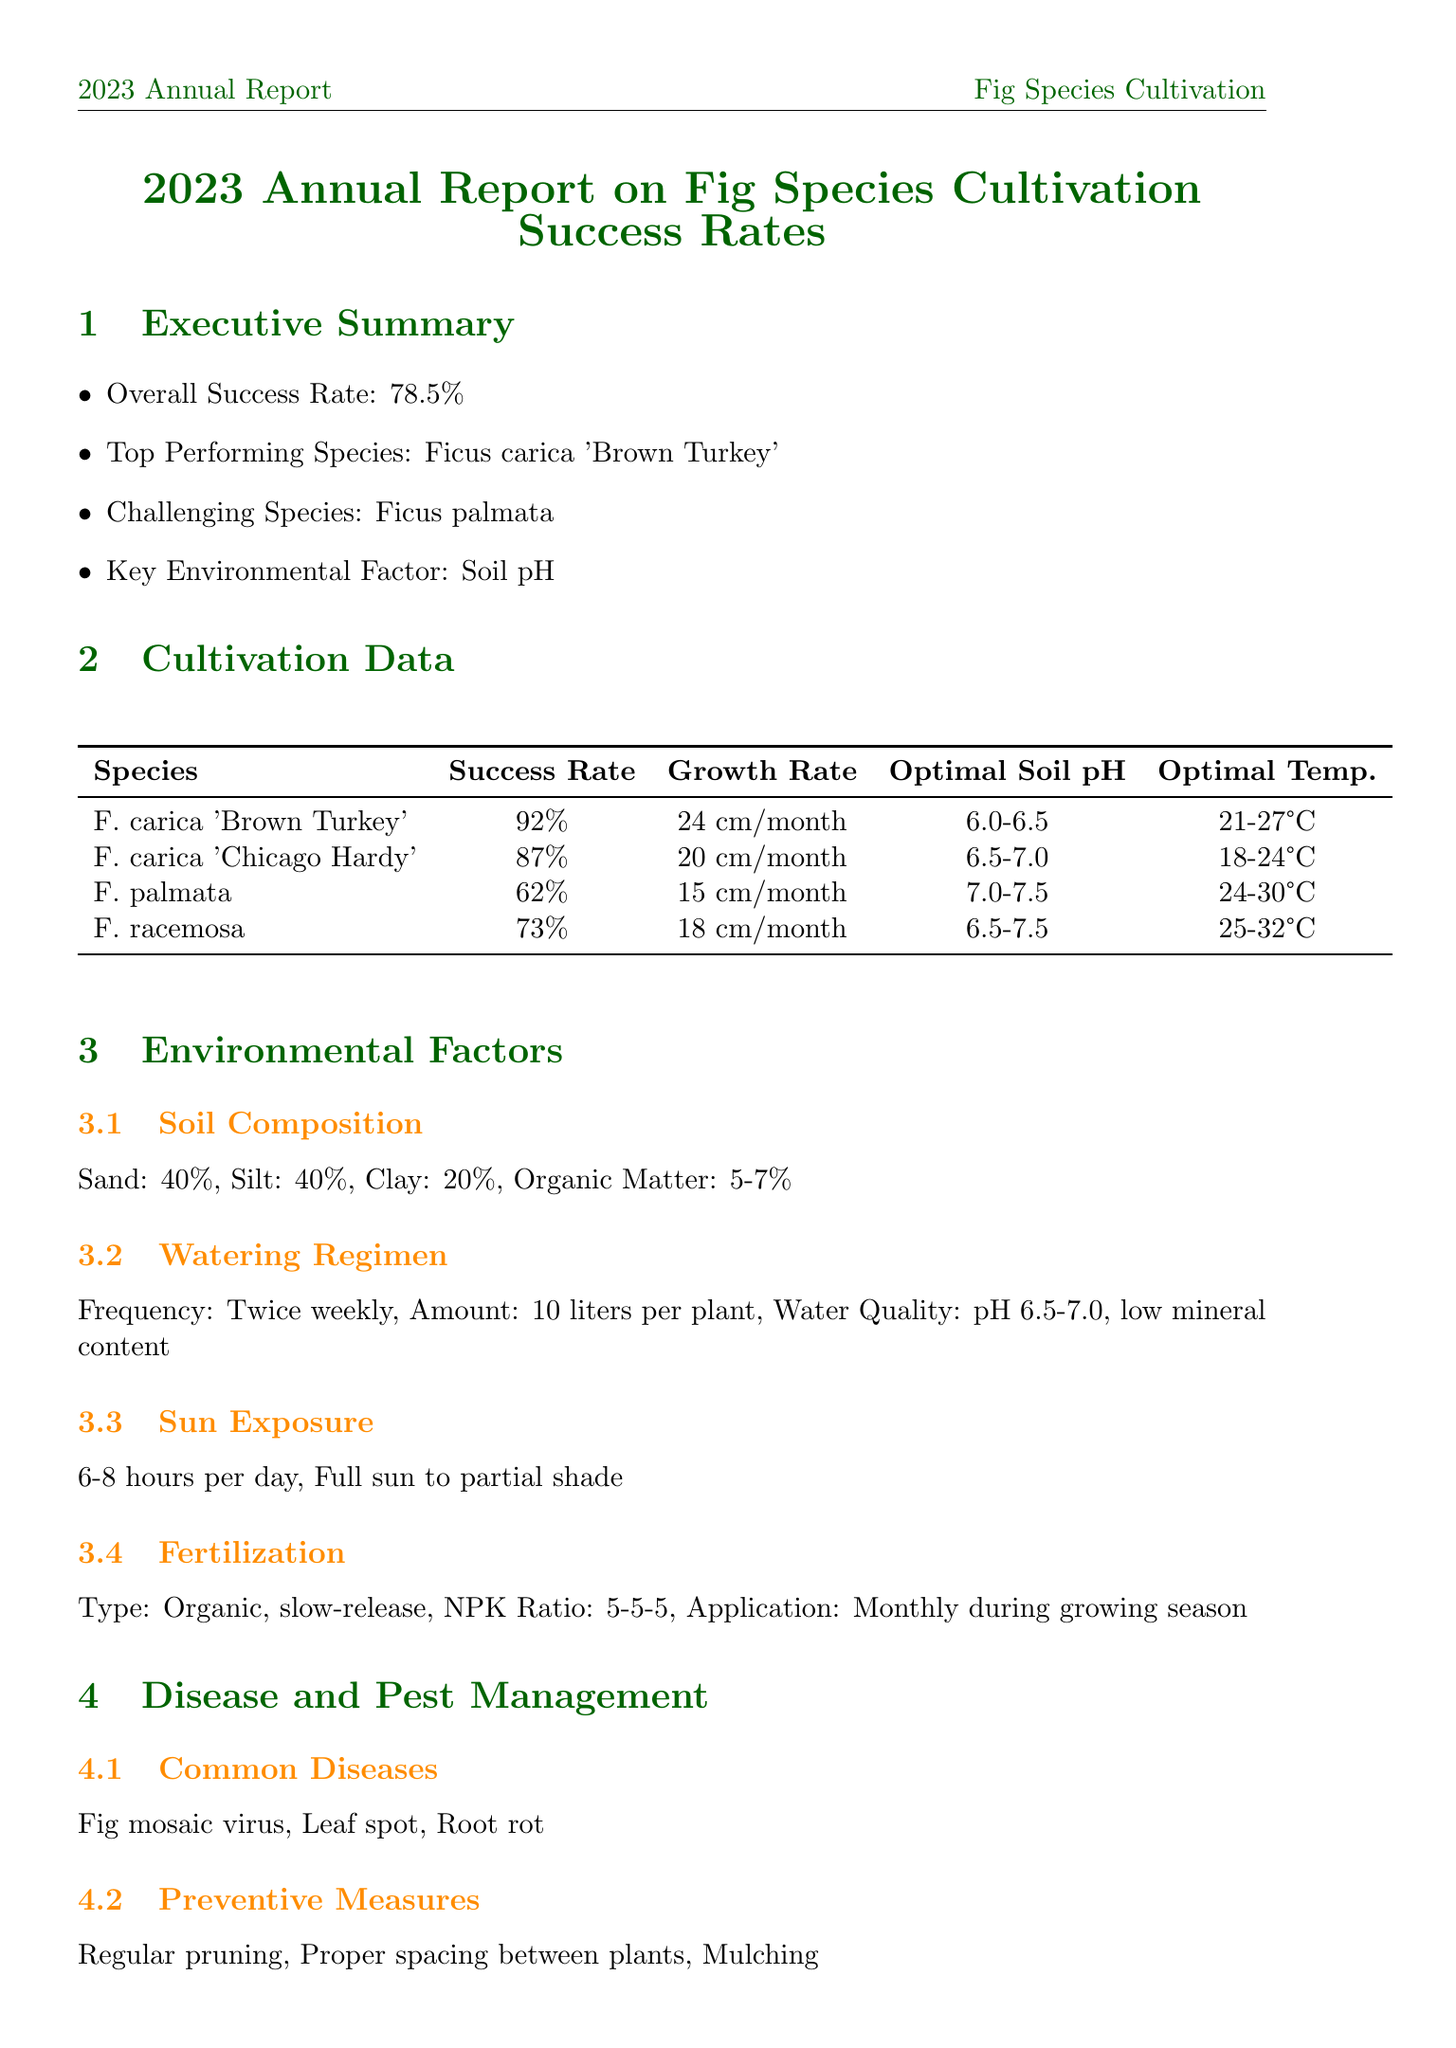what is the overall success rate? The overall success rate is provided in the executive summary of the report.
Answer: 78.5% which fig species had the highest success rate? The report lists the top-performing species in the cultivation data section.
Answer: Ficus carica 'Brown Turkey' what is the average growth rate of Ficus palmata? The average growth rate is specified in the cultivation data for each fig species.
Answer: 15 cm per month what is the key environmental factor affecting fig cultivation? This factor is mentioned in the executive summary of the report.
Answer: Soil pH what percentage of sand is in the soil composition? This percentage is provided in the environmental factors section regarding soil composition.
Answer: 40% which fig species is considered challenging? The report explicitly identifies this species in the executive summary.
Answer: Ficus palmata what is the application frequency for fertilization during the growing season? The application frequency is mentioned in the environmental factors section under fertilization.
Answer: Monthly what are the common diseases affecting fig species? The common diseases are listed in the disease and pest management section.
Answer: Fig mosaic virus, Leaf spot, Root rot what is one of the ongoing studies mentioned in the research and development section? This study is included in the ongoing studies list.
Answer: Genetic improvement for cold hardiness 